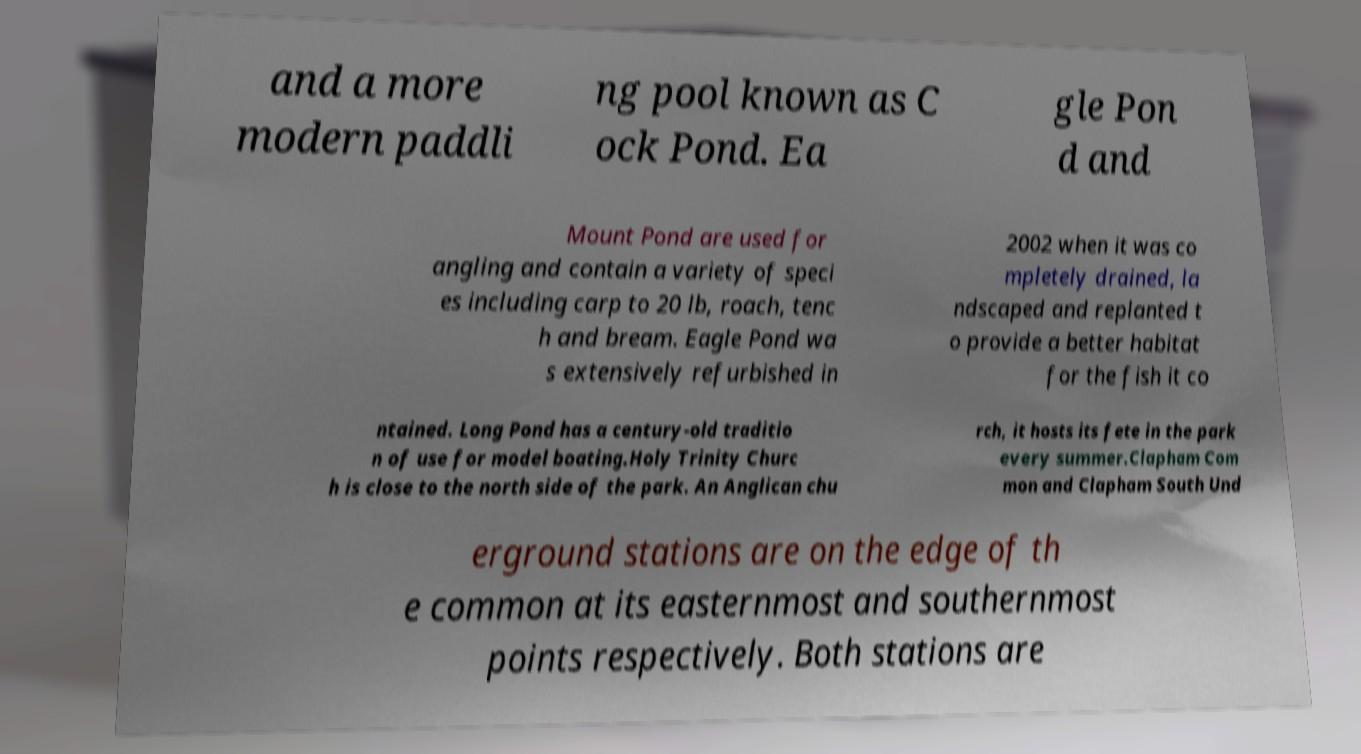Please identify and transcribe the text found in this image. and a more modern paddli ng pool known as C ock Pond. Ea gle Pon d and Mount Pond are used for angling and contain a variety of speci es including carp to 20 lb, roach, tenc h and bream. Eagle Pond wa s extensively refurbished in 2002 when it was co mpletely drained, la ndscaped and replanted t o provide a better habitat for the fish it co ntained. Long Pond has a century-old traditio n of use for model boating.Holy Trinity Churc h is close to the north side of the park. An Anglican chu rch, it hosts its fete in the park every summer.Clapham Com mon and Clapham South Und erground stations are on the edge of th e common at its easternmost and southernmost points respectively. Both stations are 